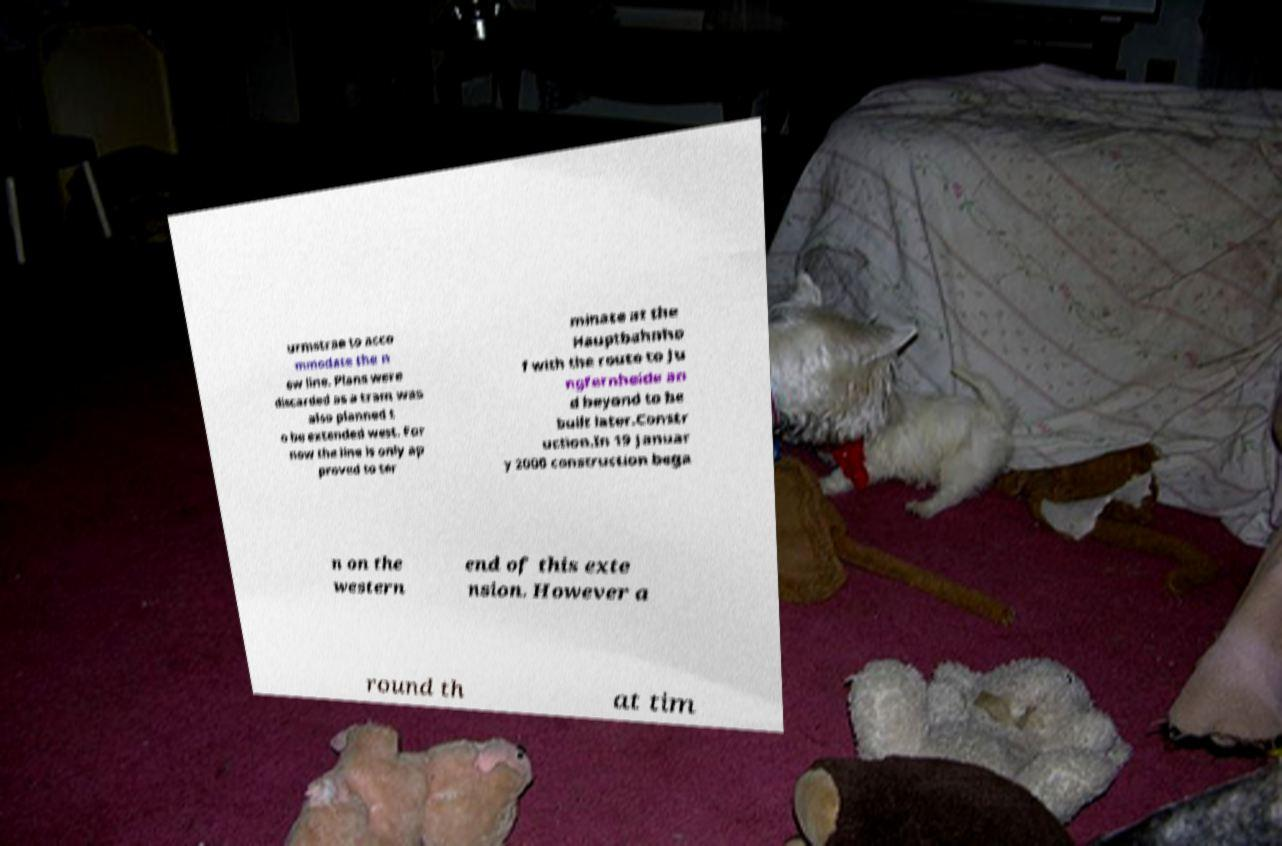There's text embedded in this image that I need extracted. Can you transcribe it verbatim? urmstrae to acco mmodate the n ew line. Plans were discarded as a tram was also planned t o be extended west. For now the line is only ap proved to ter minate at the Hauptbahnho f with the route to Ju ngfernheide an d beyond to be built later.Constr uction.In 19 Januar y 2000 construction bega n on the western end of this exte nsion. However a round th at tim 